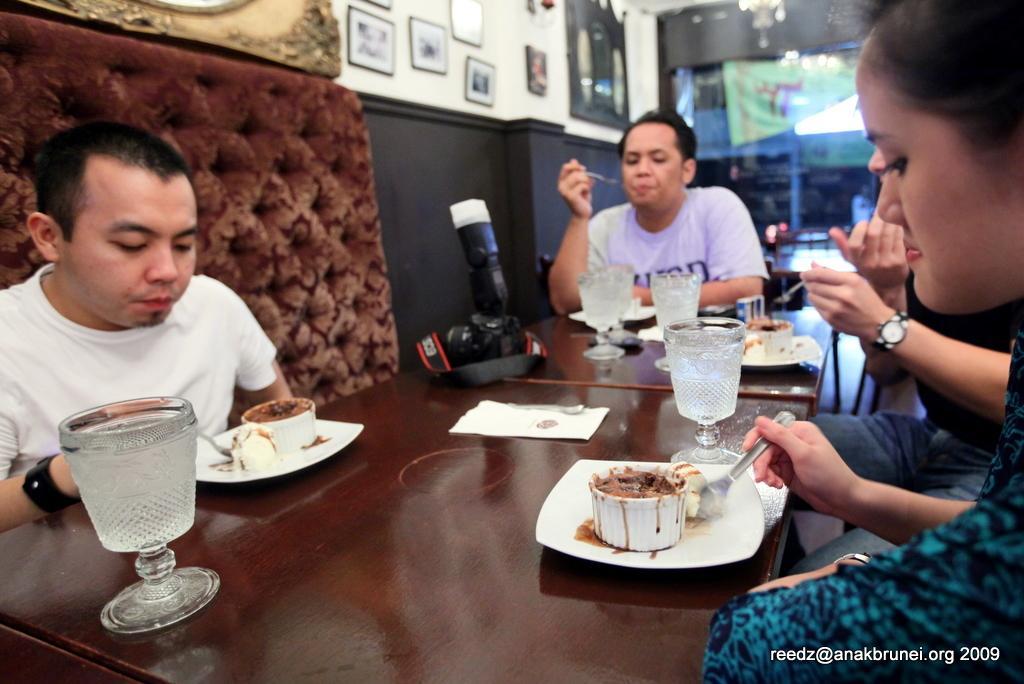Could you give a brief overview of what you see in this image? On the background we can see a wall, cupboard and few frames over a wall. Here we can see four persons sitting on chairs in front of a table and having food and on the table we can see glasses, camera, plate of food. This woman is holding a spoon in her hand. 